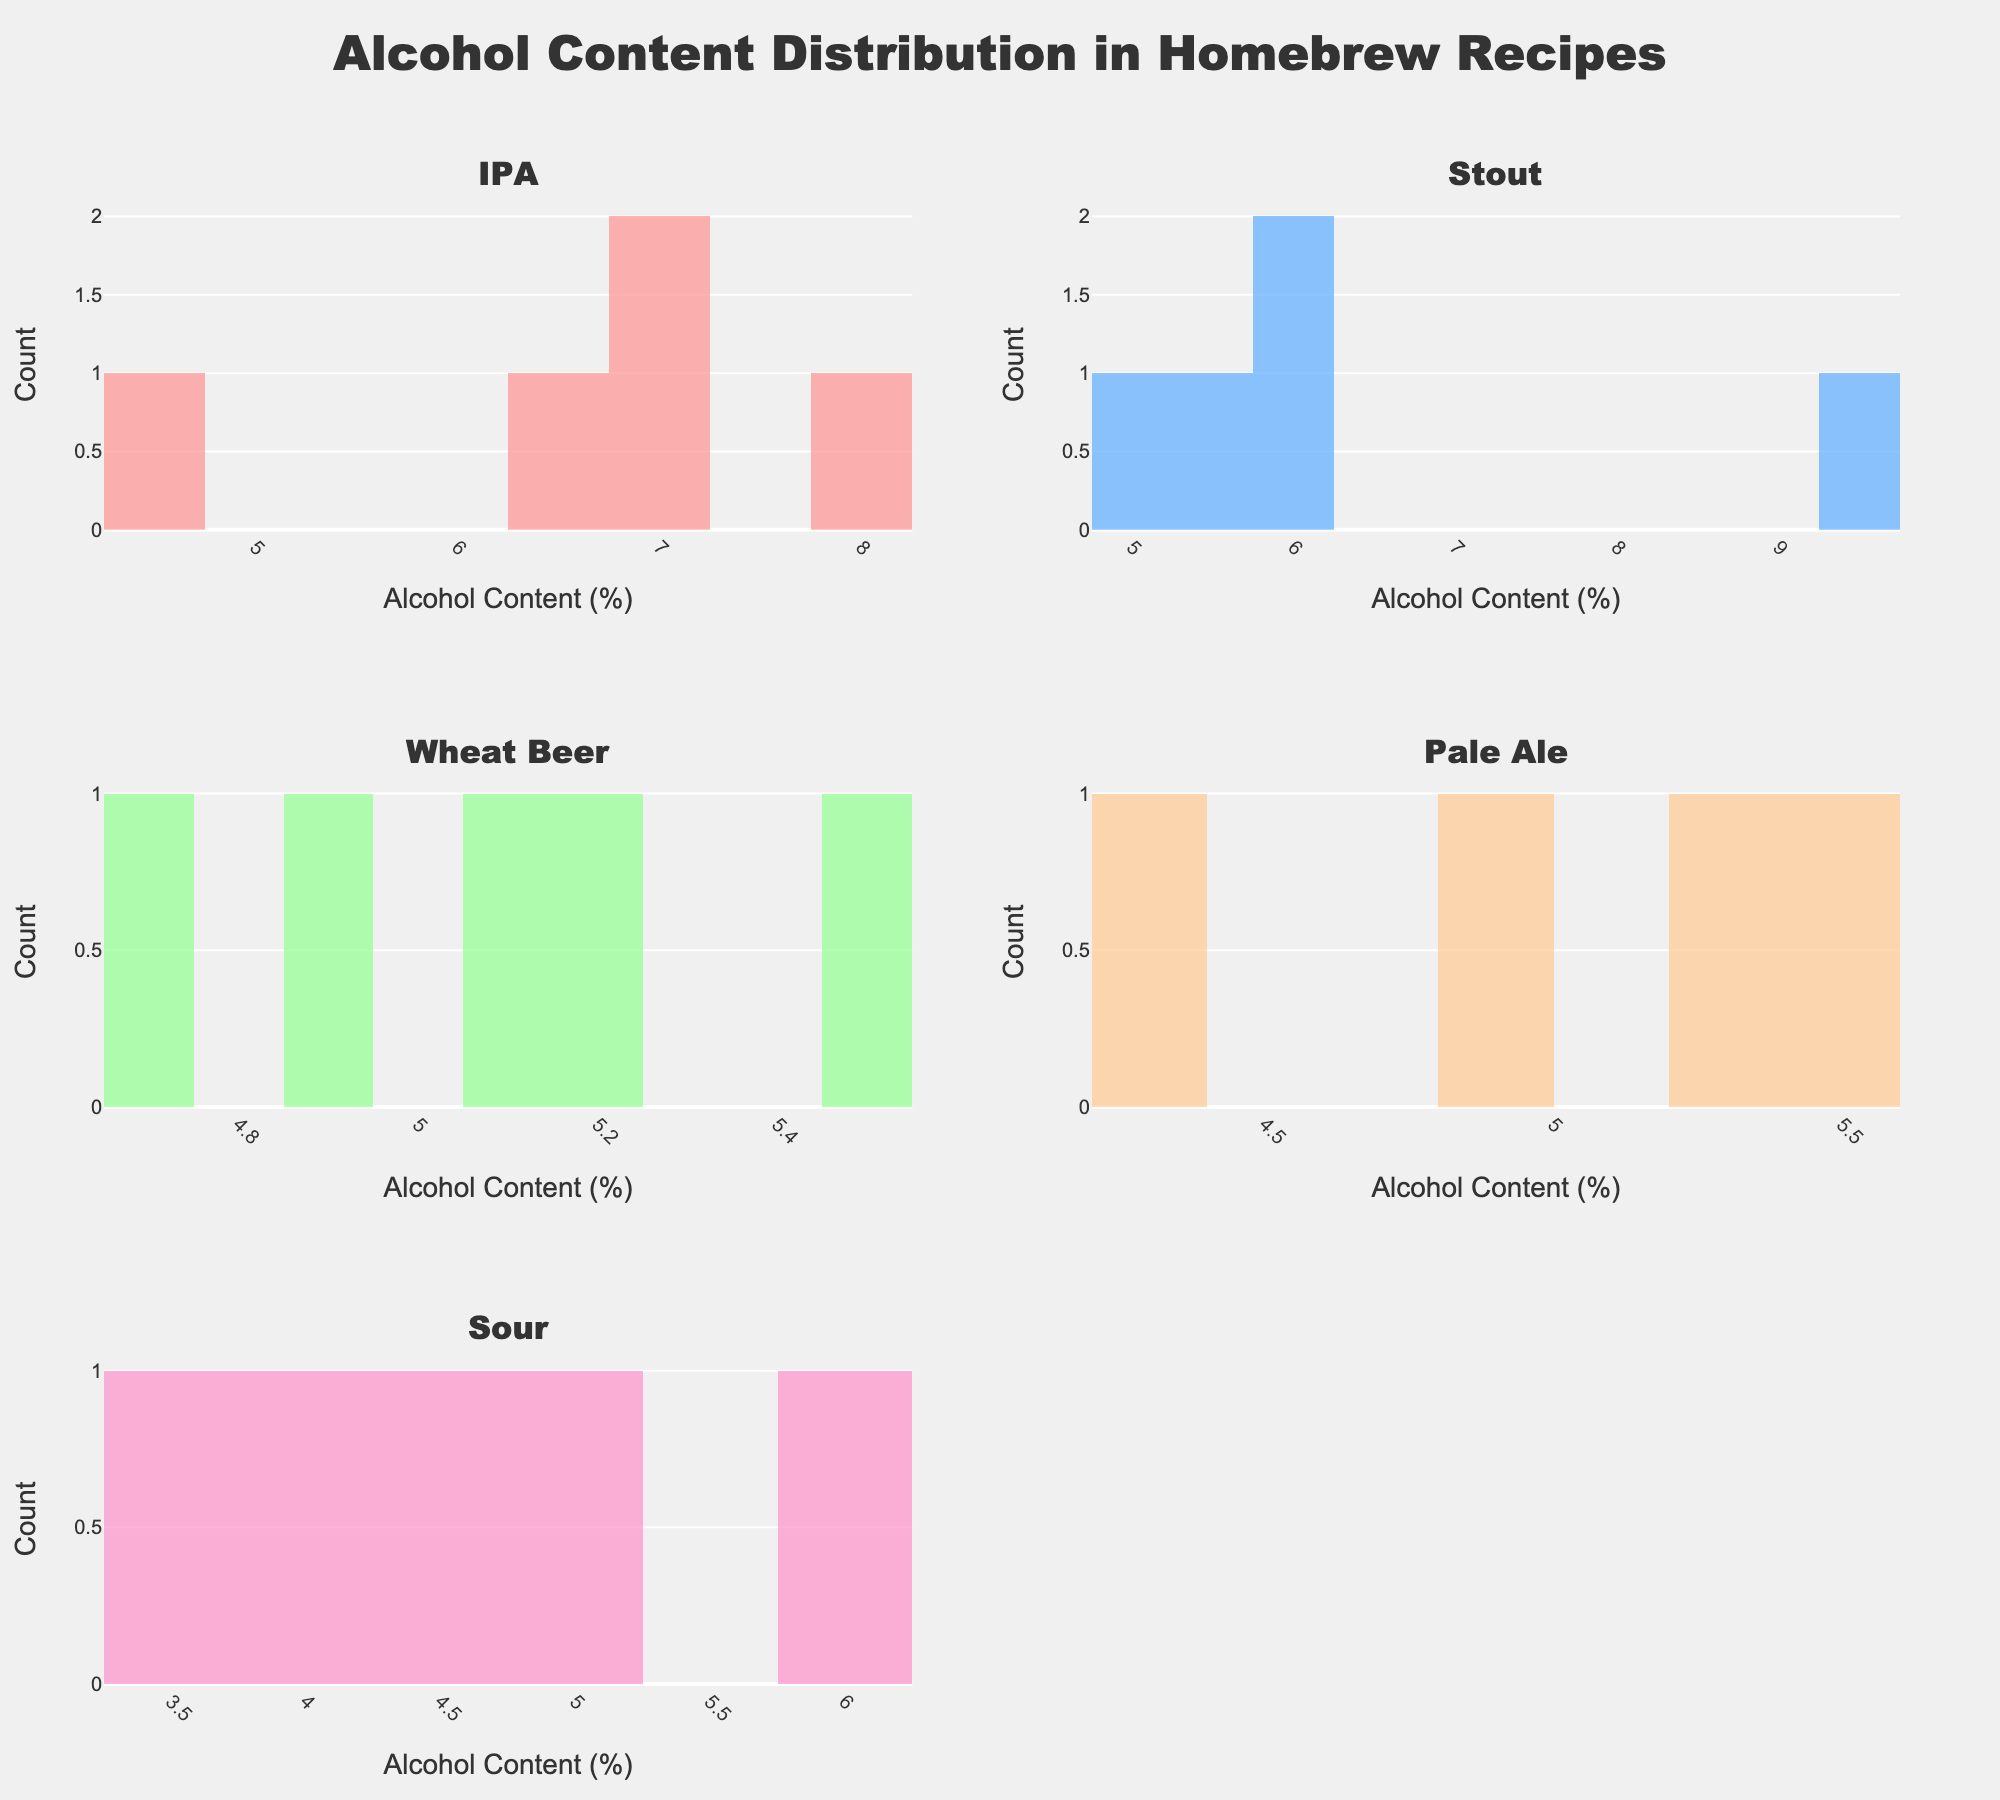What is the overall title of the figure? The title is displayed prominently at the top center of the figure above all the subplots.
Answer: Alcohol Content Distribution in Homebrew Recipes Which beer type has the highest maximum alcohol content? By analyzing the subplots, identify the largest value in each histogram, then compare them to find the maximum.
Answer: Stout What is the range of alcohol content in the IPA recipes? Locate the IPA subplot, note the minimum and maximum alcohol content values, and then calculate the difference between them.
Answer: 3.7% (8.2% - 4.5%) Which beer type shows the widest spread in alcohol content distribution? Visually compare the horizontal spread in each histogram to see which has the largest range.
Answer: Stout Which beer type has the most recipes with alcohol content above 6%? Evaluate each subplot by counting the number of recipes with alcohol content exceeding 6%.
Answer: IPA How many beer types have recipes with alcohol contents that exceed 8%? Examine each histogram to determine which ones have bars (recipes) at or above 8% alcohol content.
Answer: 2 (IPA and Stout) Which beer type has the most uniform distribution of alcohol content? Look for the histogram with bars of relatively equal height across different alcohol content ranges.
Answer: Wheat Beer What is the median alcohol content in the Pale Ale recipes? Identify the middle value (or average of the two middle values) when the alcohol contents are ordered from lowest to highest. List: 4.2, 4.8, 5.3, 5.5, 5.8.
Answer: 5.3% Between IPA and Sour, which beer type has a higher average alcohol content? Calculate the average alcohol content for each type by adding all values together and dividing by the number of recipes.
Answer: IPA Which histogram shows the highest bar? Visually scan through the subplots and find the one with the highest individual bar.
Answer: IPA 